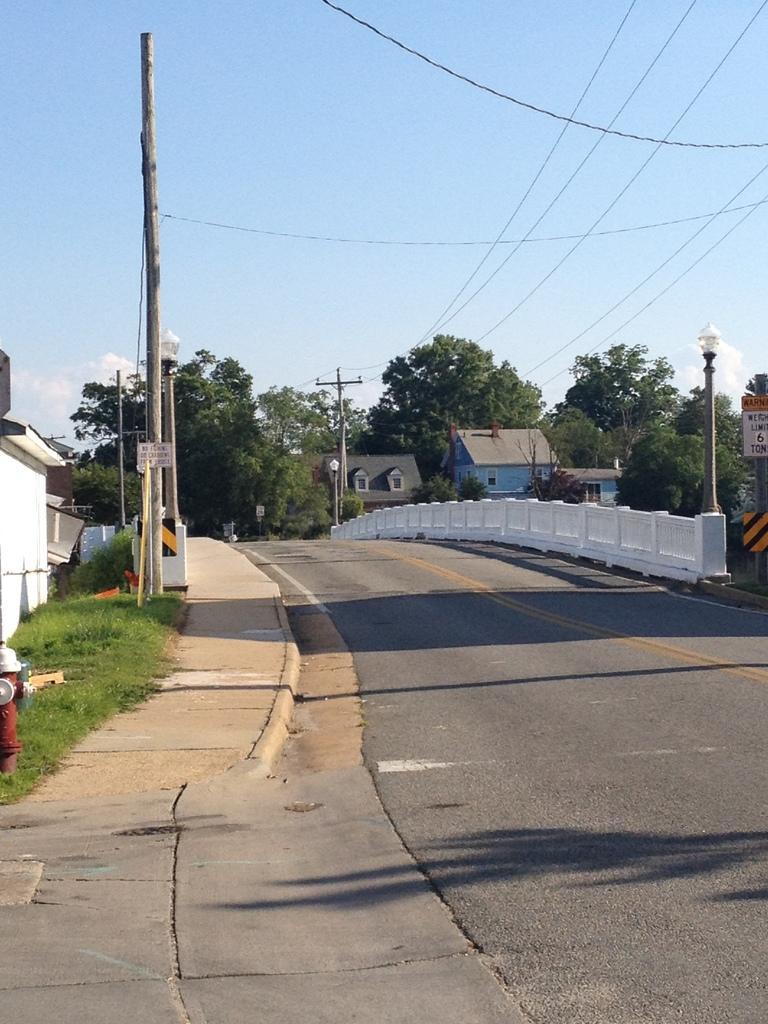Describe this image in one or two sentences. In this picture I can see the road and on both the sides I can see the poles, wires and on the left side of this image I can see the fire hydrant, grass and in the background I can see number of buildings, trees and the clear sky. 